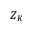<formula> <loc_0><loc_0><loc_500><loc_500>Z _ { K }</formula> 